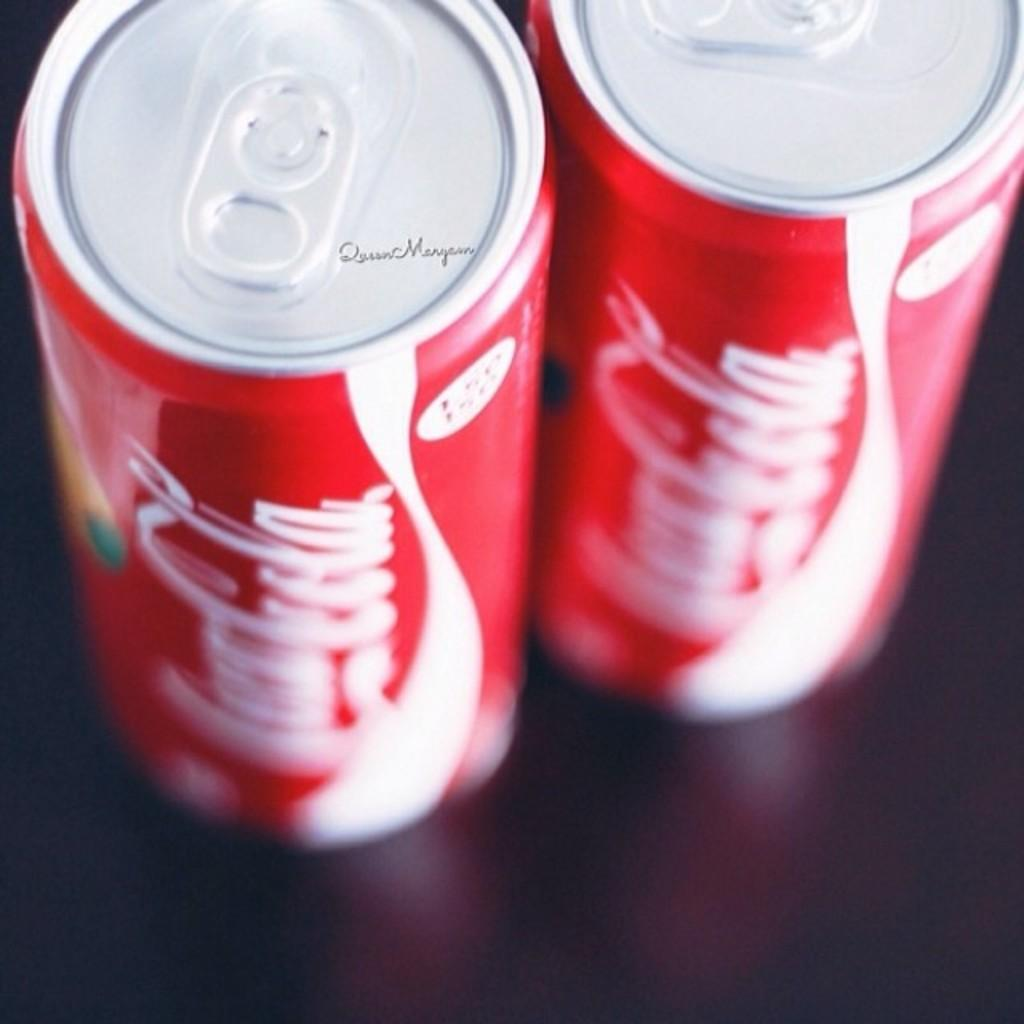<image>
Share a concise interpretation of the image provided. The two Coca Cola cans are side by side and on the lid of one is small print of Queen and something else. 